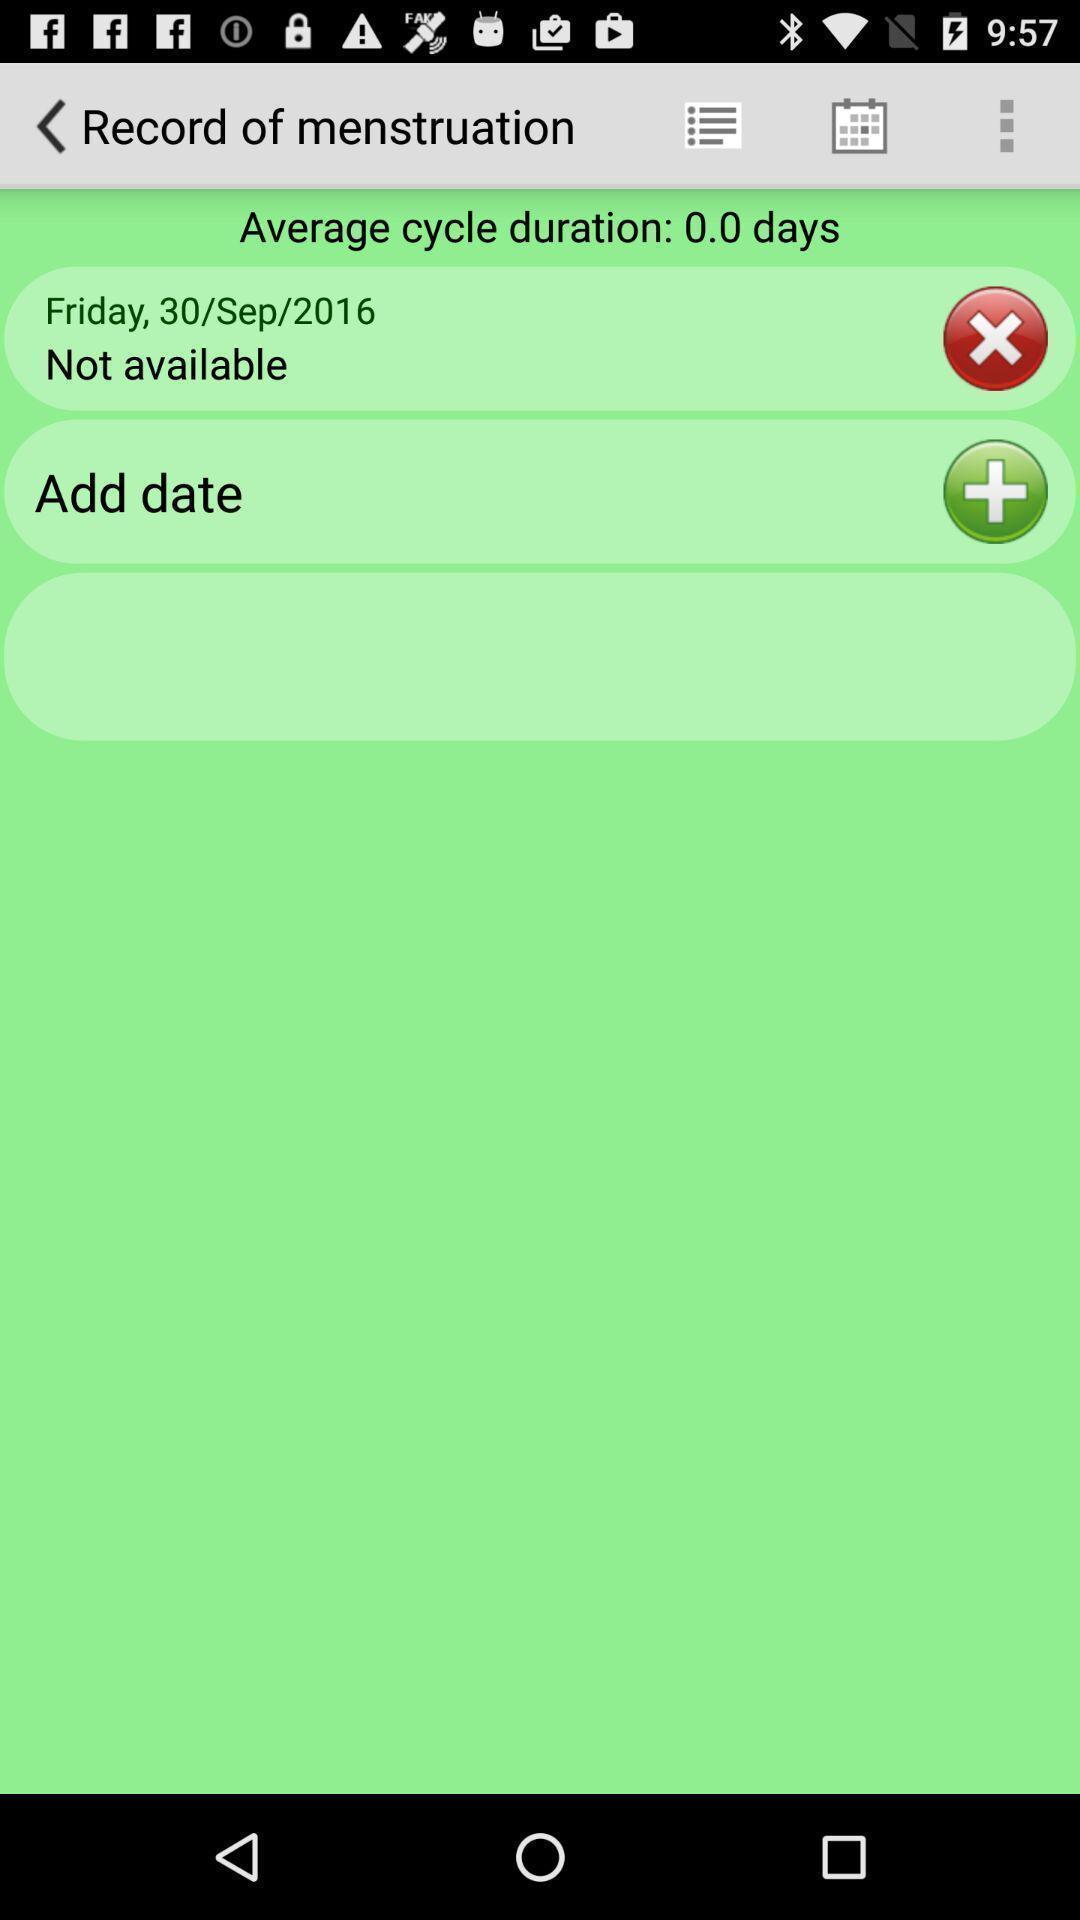Provide a description of this screenshot. Record page of periods. 